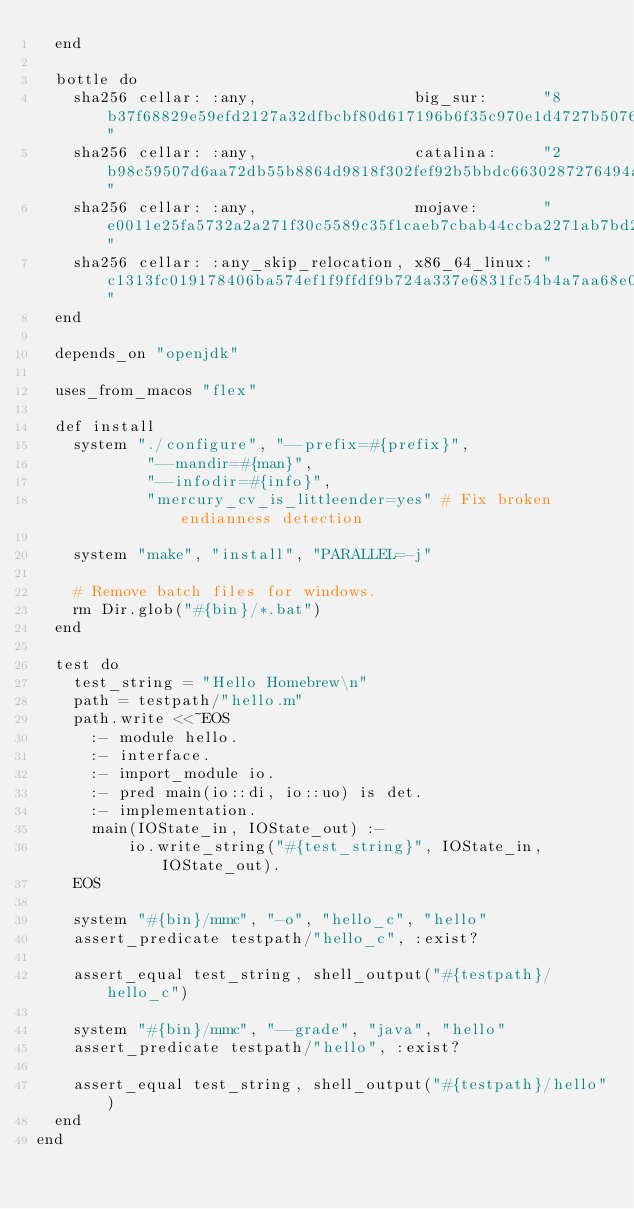Convert code to text. <code><loc_0><loc_0><loc_500><loc_500><_Ruby_>  end

  bottle do
    sha256 cellar: :any,                 big_sur:      "8b37f68829e59efd2127a32dfbcbf80d617196b6f35c970e1d4727b5076abb39"
    sha256 cellar: :any,                 catalina:     "2b98c59507d6aa72db55b8864d9818f302fef92b5bbdc6630287276494a3bc62"
    sha256 cellar: :any,                 mojave:       "e0011e25fa5732a2a271f30c5589c35f1caeb7cbab44ccba2271ab7bd2632243"
    sha256 cellar: :any_skip_relocation, x86_64_linux: "c1313fc019178406ba574ef1f9ffdf9b724a337e6831fc54b4a7aa68e02d2635"
  end

  depends_on "openjdk"

  uses_from_macos "flex"

  def install
    system "./configure", "--prefix=#{prefix}",
            "--mandir=#{man}",
            "--infodir=#{info}",
            "mercury_cv_is_littleender=yes" # Fix broken endianness detection

    system "make", "install", "PARALLEL=-j"

    # Remove batch files for windows.
    rm Dir.glob("#{bin}/*.bat")
  end

  test do
    test_string = "Hello Homebrew\n"
    path = testpath/"hello.m"
    path.write <<~EOS
      :- module hello.
      :- interface.
      :- import_module io.
      :- pred main(io::di, io::uo) is det.
      :- implementation.
      main(IOState_in, IOState_out) :-
          io.write_string("#{test_string}", IOState_in, IOState_out).
    EOS

    system "#{bin}/mmc", "-o", "hello_c", "hello"
    assert_predicate testpath/"hello_c", :exist?

    assert_equal test_string, shell_output("#{testpath}/hello_c")

    system "#{bin}/mmc", "--grade", "java", "hello"
    assert_predicate testpath/"hello", :exist?

    assert_equal test_string, shell_output("#{testpath}/hello")
  end
end
</code> 